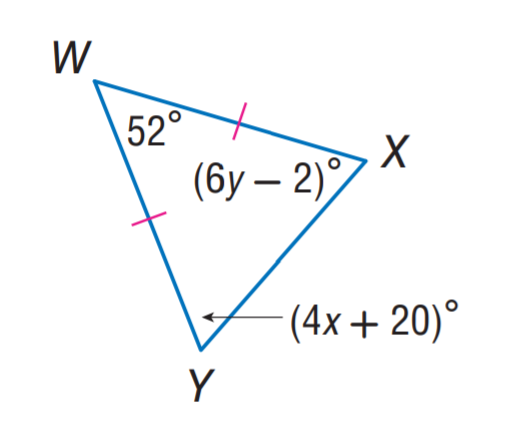Question: Find y.
Choices:
A. 9
B. 11
C. 12
D. 20
Answer with the letter. Answer: B Question: Find x.
Choices:
A. 6
B. 11
C. 12
D. 20
Answer with the letter. Answer: B 